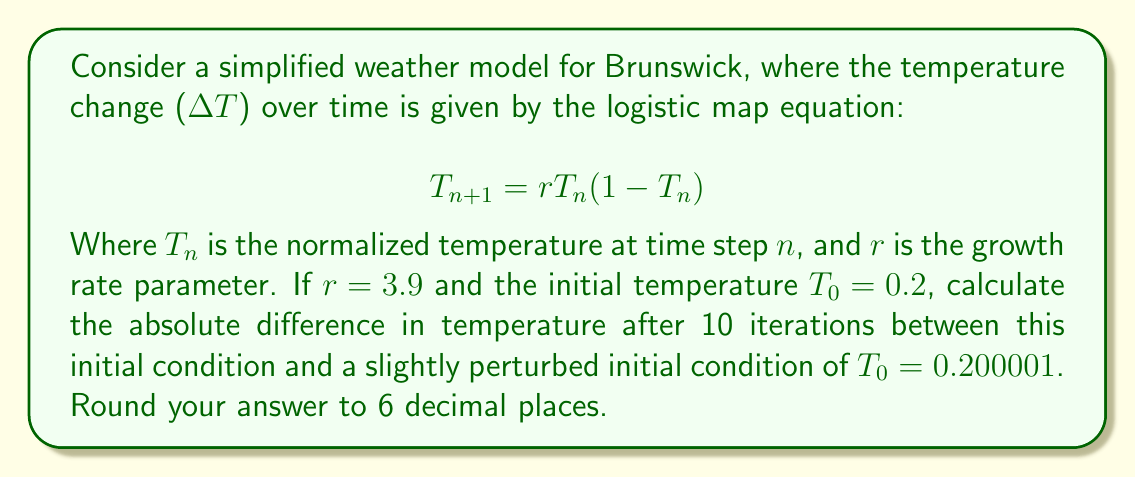What is the answer to this math problem? To solve this problem, we need to iterate the logistic map equation for both initial conditions and compare the results after 10 iterations. Let's break it down step-by-step:

1. For the original initial condition $T_0 = 0.2$:
   $T_1 = 3.9 \cdot 0.2 \cdot (1-0.2) = 0.624$
   $T_2 = 3.9 \cdot 0.624 \cdot (1-0.624) = 0.915458304$
   ...continue until $T_{10}$

2. For the perturbed initial condition $T_0 = 0.200001$:
   $T_1 = 3.9 \cdot 0.200001 \cdot (1-0.200001) = 0.624003744$
   $T_2 = 3.9 \cdot 0.624003744 \cdot (1-0.624003744) = 0.915463128$
   ...continue until $T_{10}$

3. Calculate all iterations:
   Original: $T_{10} = 0.747464668$
   Perturbed: $T_{10} = 0.745520114$

4. Calculate the absolute difference:
   $|\Delta T| = |0.747464668 - 0.745520114| = 0.001944554$

5. Round to 6 decimal places: 0.001945

This significant difference after only 10 iterations, despite a tiny initial perturbation, demonstrates the butterfly effect in the local weather system of Brunswick.
Answer: 0.001945 